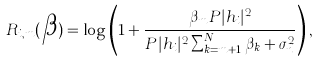Convert formula to latex. <formula><loc_0><loc_0><loc_500><loc_500>R _ { i , m } ( \boldsymbol \beta ) = \log \left ( 1 + \frac { \beta _ { m } P | h _ { i } | ^ { 2 } } { P | h _ { i } | ^ { 2 } \sum _ { k = m + 1 } ^ { N } \beta _ { k } + \sigma _ { n } ^ { 2 } } \right ) ,</formula> 